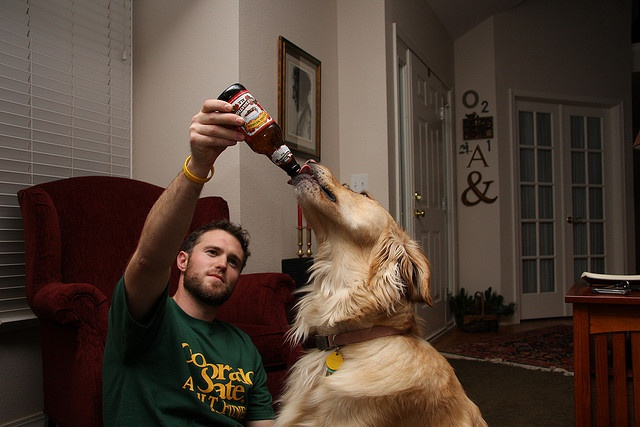Describe the objects in this image and their specific colors. I can see people in gray, black, maroon, and brown tones, dog in gray, tan, and maroon tones, chair in gray, black, and maroon tones, dining table in gray, black, maroon, and brown tones, and bottle in gray, black, maroon, lightgray, and darkgray tones in this image. 